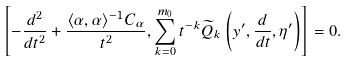<formula> <loc_0><loc_0><loc_500><loc_500>\left [ - \frac { d ^ { 2 } } { d t ^ { 2 } } + \frac { \langle \alpha , \alpha \rangle ^ { - 1 } C _ { \alpha } } { t ^ { 2 } } , \sum _ { k = 0 } ^ { m _ { 0 } } t ^ { - k } \widetilde { Q } _ { k } \left ( y ^ { \prime } , \frac { d } { d t } , \eta ^ { \prime } \right ) \right ] = 0 .</formula> 